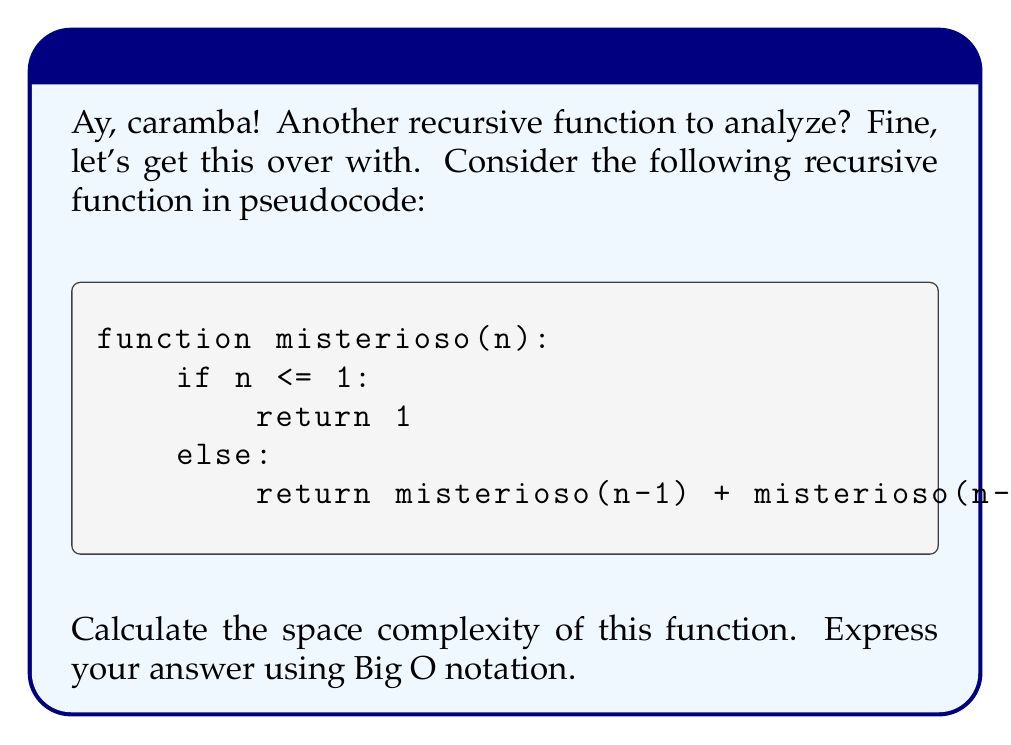Help me with this question. Bien, vamos a analizar esto paso a paso:

1. First, we need to understand what space complexity means. It's the amount of memory space required by the algorithm as a function of the input size.

2. In recursive functions, the space complexity is often determined by the maximum depth of the recursion stack.

3. Let's trace the function calls for $n = 5$:
   ```
   misterioso(5)
   ├── misterioso(4)
   │   ├── misterioso(3)
   │   │   ├── misterioso(2)
   │   │   │   ├── misterioso(1)
   │   │   │   └── misterioso(0)
   │   │   └── misterioso(1)
   │   └── misterioso(2)
   │       ├── misterioso(1)
   │       └── misterioso(0)
   └── misterioso(3)
       ├── misterioso(2)
       │   ├── misterioso(1)
       │   └── misterioso(0)
       └── misterioso(1)
   ```

4. We can see that the maximum depth of the recursion is $n$. At each level, we need to store some information (like the value of $n$ and the return address).

5. The amount of memory used at each level of recursion is constant, let's call it $c$.

6. Therefore, the total space used is proportional to the depth of recursion: $c * n$.

7. In Big O notation, we ignore constants, so the space complexity is $O(n)$.

Así que, aunque esta función parece complicada, su complejidad espacial es bastante simple.
Answer: $O(n)$ 